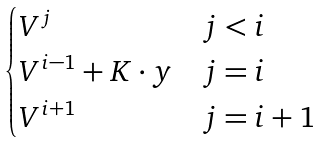<formula> <loc_0><loc_0><loc_500><loc_500>\begin{cases} V ^ { j } & j < i \\ V ^ { i - 1 } + K \cdot y & j = i \\ V ^ { i + 1 } & j = i + 1 \end{cases}</formula> 